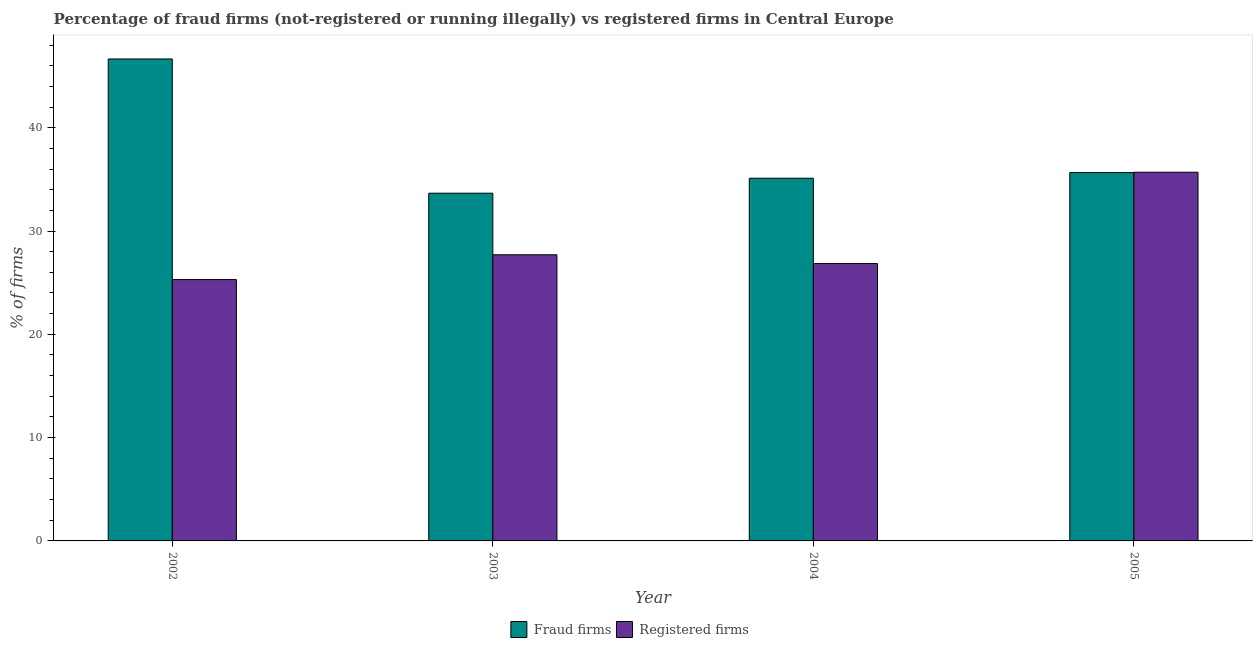How many different coloured bars are there?
Offer a terse response. 2. Are the number of bars on each tick of the X-axis equal?
Offer a very short reply. Yes. How many bars are there on the 4th tick from the left?
Ensure brevity in your answer.  2. In how many cases, is the number of bars for a given year not equal to the number of legend labels?
Your response must be concise. 0. What is the percentage of registered firms in 2004?
Give a very brief answer. 26.85. Across all years, what is the maximum percentage of fraud firms?
Make the answer very short. 46.65. Across all years, what is the minimum percentage of fraud firms?
Provide a short and direct response. 33.66. What is the total percentage of registered firms in the graph?
Your response must be concise. 115.54. What is the difference between the percentage of fraud firms in 2002 and that in 2003?
Make the answer very short. 12.99. What is the difference between the percentage of registered firms in 2005 and the percentage of fraud firms in 2002?
Your answer should be very brief. 10.39. What is the average percentage of registered firms per year?
Offer a very short reply. 28.89. In how many years, is the percentage of fraud firms greater than 38 %?
Your response must be concise. 1. What is the ratio of the percentage of fraud firms in 2002 to that in 2005?
Make the answer very short. 1.31. Is the percentage of registered firms in 2004 less than that in 2005?
Give a very brief answer. Yes. Is the difference between the percentage of fraud firms in 2003 and 2004 greater than the difference between the percentage of registered firms in 2003 and 2004?
Provide a short and direct response. No. What is the difference between the highest and the second highest percentage of registered firms?
Your answer should be very brief. 7.99. What is the difference between the highest and the lowest percentage of registered firms?
Offer a very short reply. 10.39. In how many years, is the percentage of fraud firms greater than the average percentage of fraud firms taken over all years?
Your answer should be compact. 1. Is the sum of the percentage of registered firms in 2002 and 2005 greater than the maximum percentage of fraud firms across all years?
Make the answer very short. Yes. What does the 1st bar from the left in 2003 represents?
Provide a succinct answer. Fraud firms. What does the 1st bar from the right in 2004 represents?
Your answer should be very brief. Registered firms. How many bars are there?
Your answer should be very brief. 8. How many years are there in the graph?
Provide a short and direct response. 4. What is the difference between two consecutive major ticks on the Y-axis?
Ensure brevity in your answer.  10. Are the values on the major ticks of Y-axis written in scientific E-notation?
Give a very brief answer. No. Where does the legend appear in the graph?
Your answer should be very brief. Bottom center. How many legend labels are there?
Provide a succinct answer. 2. How are the legend labels stacked?
Give a very brief answer. Horizontal. What is the title of the graph?
Provide a short and direct response. Percentage of fraud firms (not-registered or running illegally) vs registered firms in Central Europe. Does "From Government" appear as one of the legend labels in the graph?
Offer a very short reply. No. What is the label or title of the X-axis?
Keep it short and to the point. Year. What is the label or title of the Y-axis?
Keep it short and to the point. % of firms. What is the % of firms in Fraud firms in 2002?
Give a very brief answer. 46.65. What is the % of firms in Registered firms in 2002?
Provide a short and direct response. 25.3. What is the % of firms in Fraud firms in 2003?
Your answer should be compact. 33.66. What is the % of firms of Registered firms in 2003?
Offer a terse response. 27.7. What is the % of firms in Fraud firms in 2004?
Your response must be concise. 35.11. What is the % of firms in Registered firms in 2004?
Provide a succinct answer. 26.85. What is the % of firms in Fraud firms in 2005?
Keep it short and to the point. 35.66. What is the % of firms of Registered firms in 2005?
Your response must be concise. 35.69. Across all years, what is the maximum % of firms of Fraud firms?
Your response must be concise. 46.65. Across all years, what is the maximum % of firms in Registered firms?
Offer a terse response. 35.69. Across all years, what is the minimum % of firms in Fraud firms?
Give a very brief answer. 33.66. Across all years, what is the minimum % of firms in Registered firms?
Make the answer very short. 25.3. What is the total % of firms of Fraud firms in the graph?
Offer a terse response. 151.08. What is the total % of firms of Registered firms in the graph?
Provide a short and direct response. 115.54. What is the difference between the % of firms of Fraud firms in 2002 and that in 2003?
Your answer should be compact. 12.99. What is the difference between the % of firms in Fraud firms in 2002 and that in 2004?
Make the answer very short. 11.54. What is the difference between the % of firms in Registered firms in 2002 and that in 2004?
Your response must be concise. -1.55. What is the difference between the % of firms in Fraud firms in 2002 and that in 2005?
Provide a succinct answer. 11. What is the difference between the % of firms in Registered firms in 2002 and that in 2005?
Your answer should be compact. -10.39. What is the difference between the % of firms in Fraud firms in 2003 and that in 2004?
Offer a very short reply. -1.45. What is the difference between the % of firms of Fraud firms in 2003 and that in 2005?
Keep it short and to the point. -2. What is the difference between the % of firms of Registered firms in 2003 and that in 2005?
Your answer should be very brief. -7.99. What is the difference between the % of firms of Fraud firms in 2004 and that in 2005?
Ensure brevity in your answer.  -0.55. What is the difference between the % of firms in Registered firms in 2004 and that in 2005?
Keep it short and to the point. -8.84. What is the difference between the % of firms in Fraud firms in 2002 and the % of firms in Registered firms in 2003?
Give a very brief answer. 18.95. What is the difference between the % of firms in Fraud firms in 2002 and the % of firms in Registered firms in 2004?
Provide a succinct answer. 19.8. What is the difference between the % of firms of Fraud firms in 2002 and the % of firms of Registered firms in 2005?
Provide a succinct answer. 10.96. What is the difference between the % of firms of Fraud firms in 2003 and the % of firms of Registered firms in 2004?
Ensure brevity in your answer.  6.81. What is the difference between the % of firms of Fraud firms in 2003 and the % of firms of Registered firms in 2005?
Ensure brevity in your answer.  -2.03. What is the difference between the % of firms of Fraud firms in 2004 and the % of firms of Registered firms in 2005?
Your response must be concise. -0.58. What is the average % of firms of Fraud firms per year?
Offer a very short reply. 37.77. What is the average % of firms in Registered firms per year?
Ensure brevity in your answer.  28.89. In the year 2002, what is the difference between the % of firms of Fraud firms and % of firms of Registered firms?
Your answer should be compact. 21.35. In the year 2003, what is the difference between the % of firms of Fraud firms and % of firms of Registered firms?
Provide a short and direct response. 5.96. In the year 2004, what is the difference between the % of firms of Fraud firms and % of firms of Registered firms?
Ensure brevity in your answer.  8.26. In the year 2005, what is the difference between the % of firms of Fraud firms and % of firms of Registered firms?
Provide a succinct answer. -0.03. What is the ratio of the % of firms of Fraud firms in 2002 to that in 2003?
Make the answer very short. 1.39. What is the ratio of the % of firms in Registered firms in 2002 to that in 2003?
Your answer should be very brief. 0.91. What is the ratio of the % of firms of Fraud firms in 2002 to that in 2004?
Offer a terse response. 1.33. What is the ratio of the % of firms in Registered firms in 2002 to that in 2004?
Offer a very short reply. 0.94. What is the ratio of the % of firms of Fraud firms in 2002 to that in 2005?
Offer a terse response. 1.31. What is the ratio of the % of firms of Registered firms in 2002 to that in 2005?
Your answer should be compact. 0.71. What is the ratio of the % of firms in Fraud firms in 2003 to that in 2004?
Provide a short and direct response. 0.96. What is the ratio of the % of firms in Registered firms in 2003 to that in 2004?
Offer a terse response. 1.03. What is the ratio of the % of firms of Fraud firms in 2003 to that in 2005?
Give a very brief answer. 0.94. What is the ratio of the % of firms of Registered firms in 2003 to that in 2005?
Give a very brief answer. 0.78. What is the ratio of the % of firms in Fraud firms in 2004 to that in 2005?
Your answer should be very brief. 0.98. What is the ratio of the % of firms of Registered firms in 2004 to that in 2005?
Keep it short and to the point. 0.75. What is the difference between the highest and the second highest % of firms in Fraud firms?
Provide a short and direct response. 11. What is the difference between the highest and the second highest % of firms of Registered firms?
Provide a short and direct response. 7.99. What is the difference between the highest and the lowest % of firms of Fraud firms?
Offer a very short reply. 12.99. What is the difference between the highest and the lowest % of firms in Registered firms?
Your answer should be compact. 10.39. 